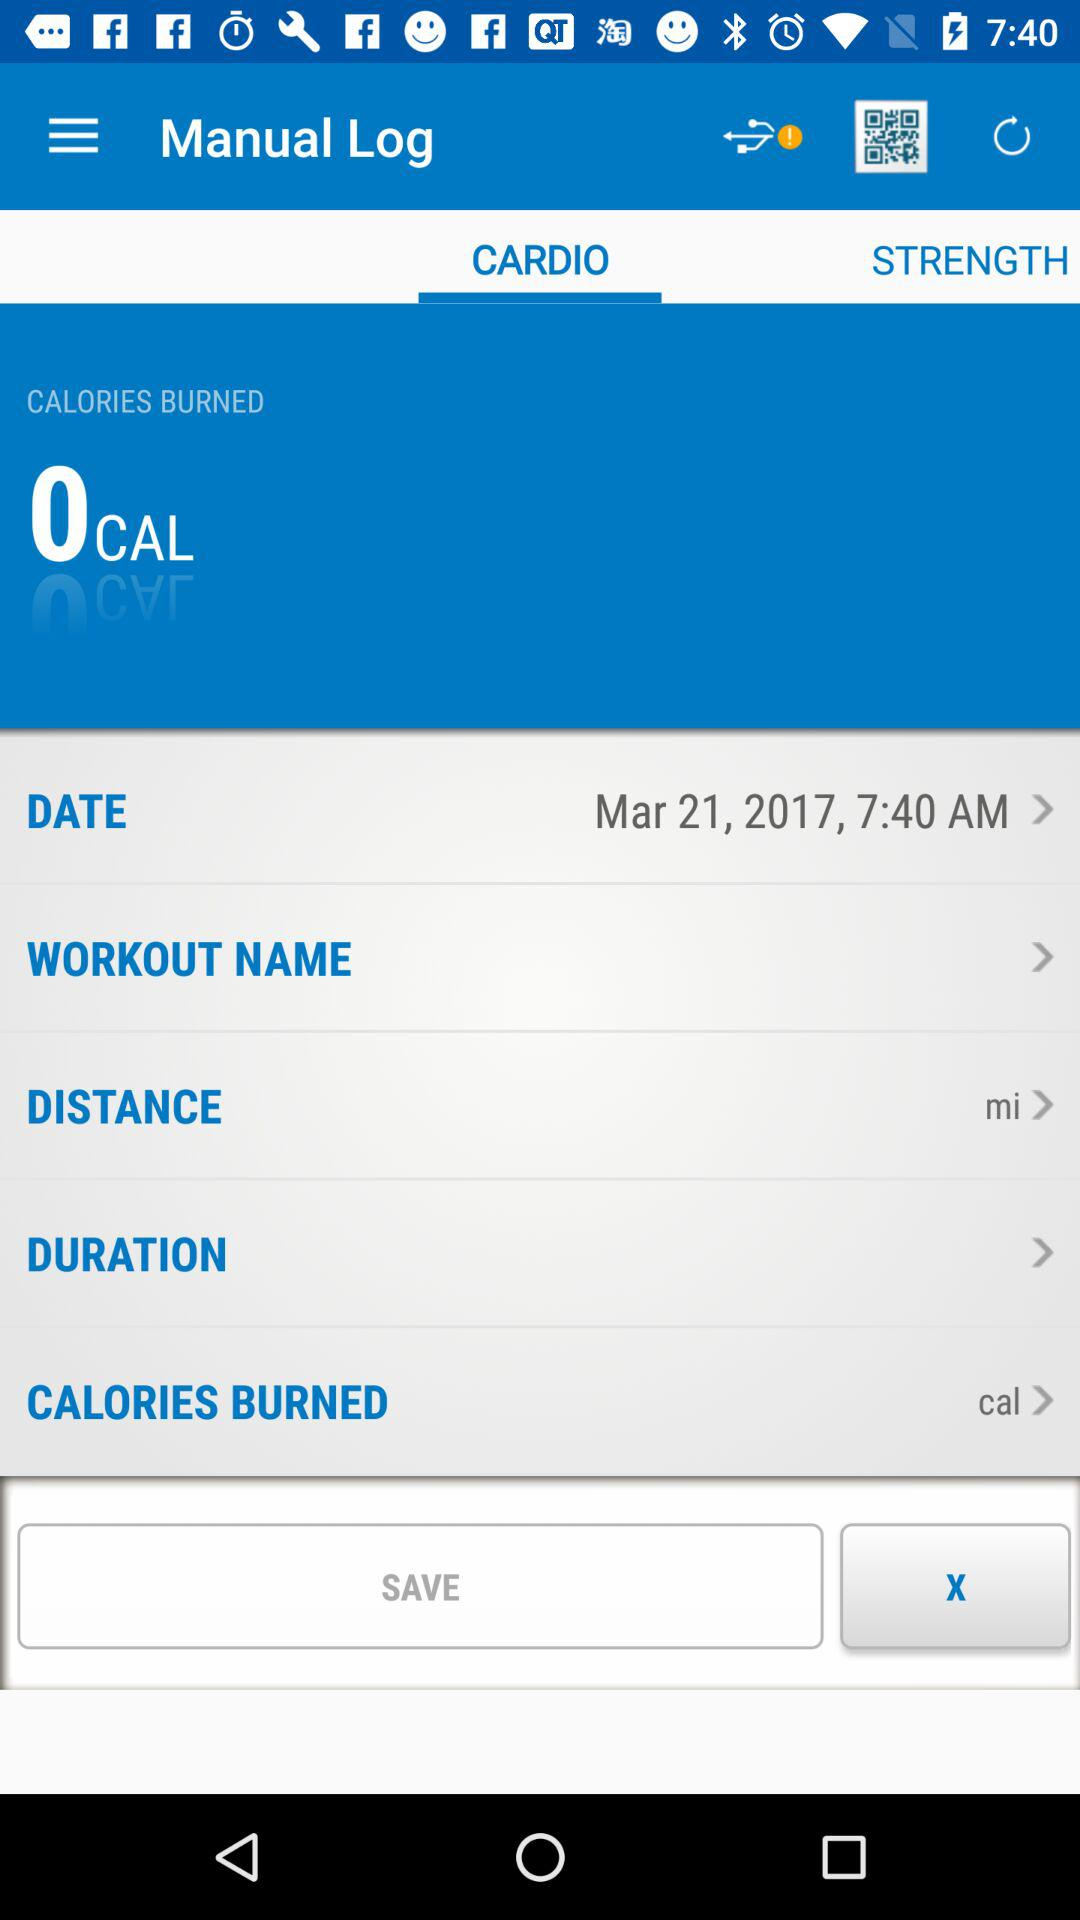What is the unit of distance? The unit of distance is miles. 